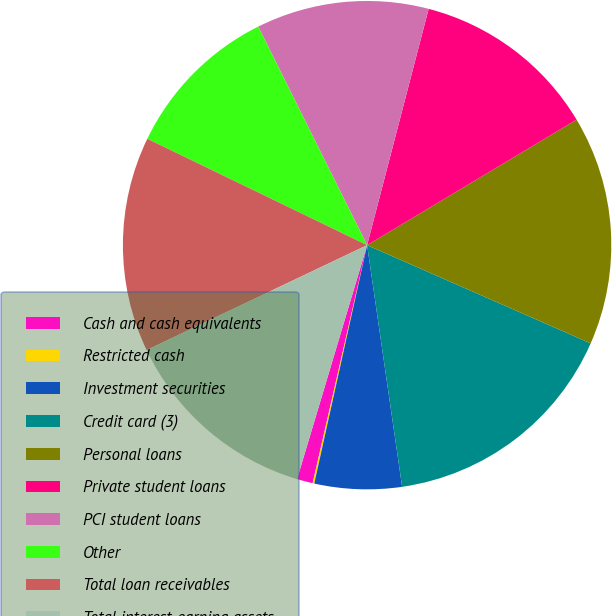<chart> <loc_0><loc_0><loc_500><loc_500><pie_chart><fcel>Cash and cash equivalents<fcel>Restricted cash<fcel>Investment securities<fcel>Credit card (3)<fcel>Personal loans<fcel>Private student loans<fcel>PCI student loans<fcel>Other<fcel>Total loan receivables<fcel>Total interest-earning assets<nl><fcel>1.05%<fcel>0.11%<fcel>5.76%<fcel>16.12%<fcel>15.18%<fcel>12.35%<fcel>11.41%<fcel>10.47%<fcel>14.24%<fcel>13.3%<nl></chart> 